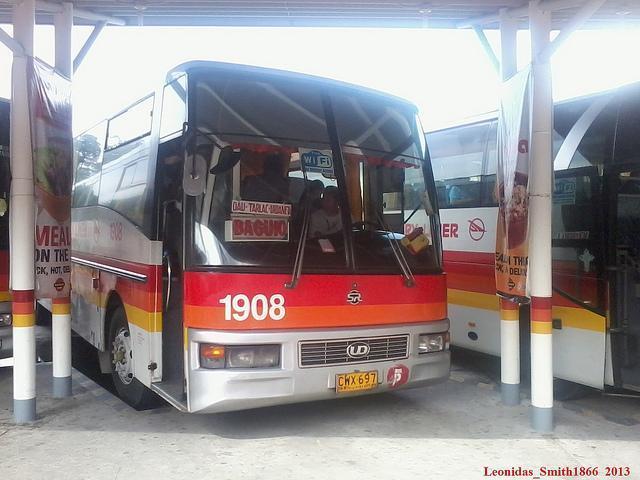How many buses are there?
Give a very brief answer. 3. How many giraffes are pictured?
Give a very brief answer. 0. 